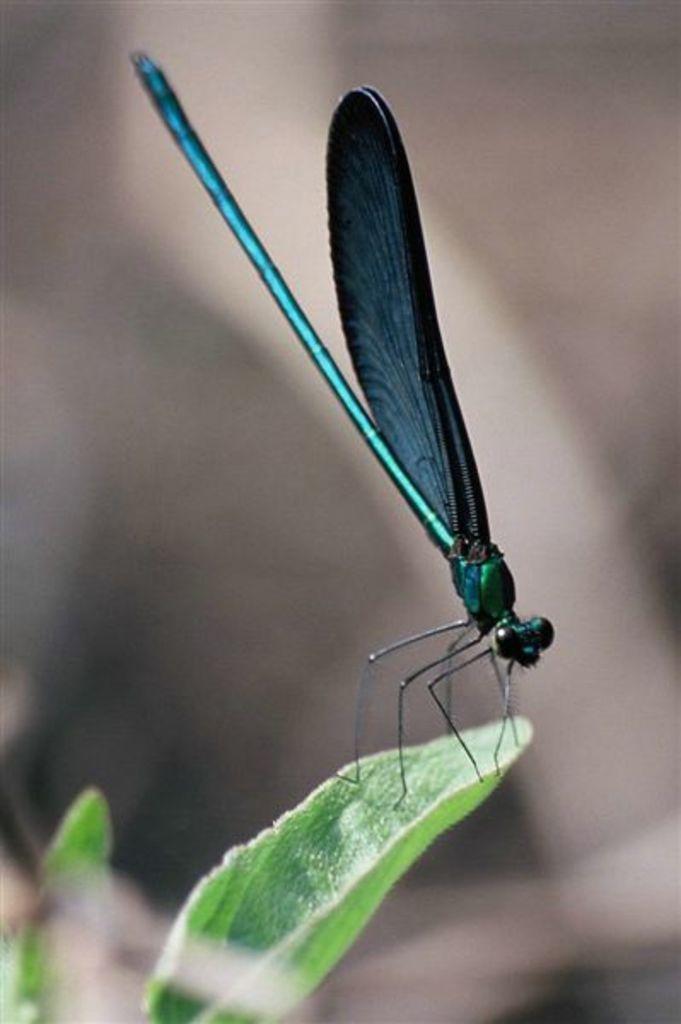Describe this image in one or two sentences. In this image we can see an insect on the leaf. There are few leaves in the image. There is a blur background in the image. 